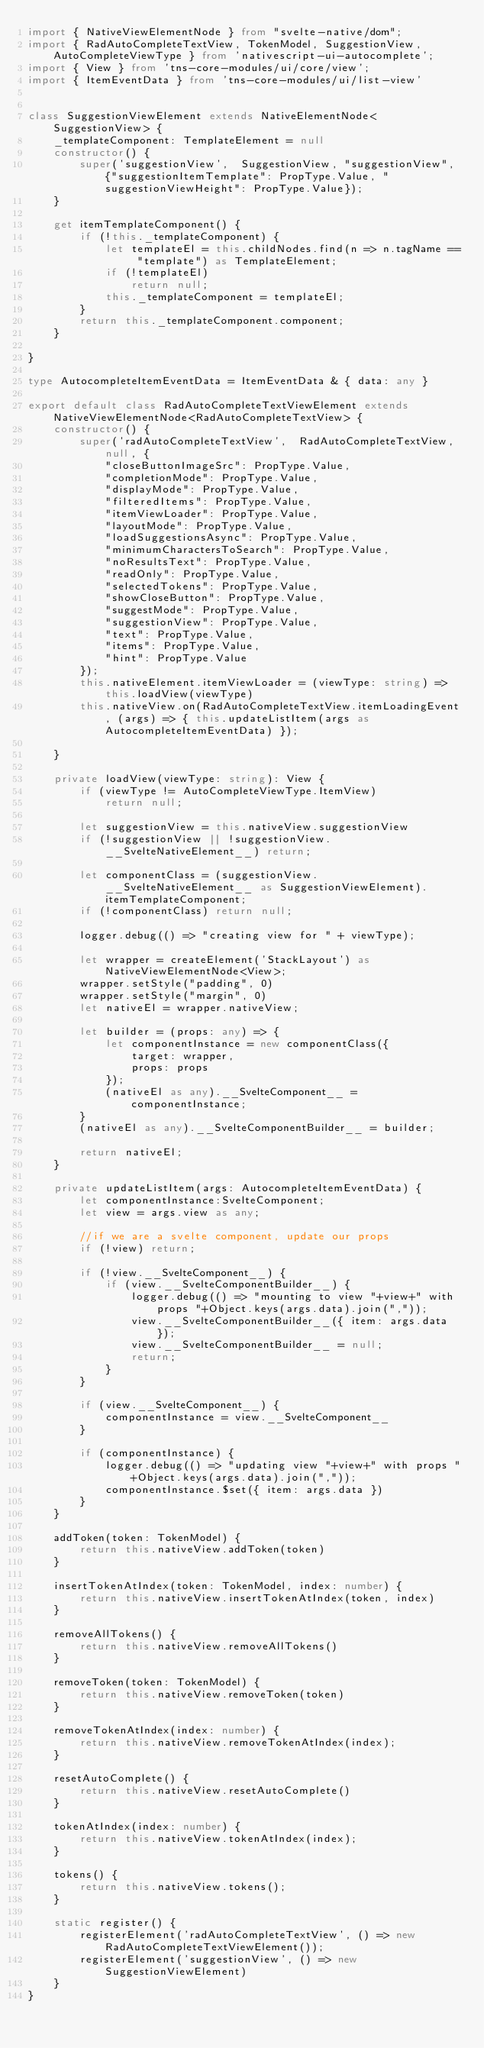Convert code to text. <code><loc_0><loc_0><loc_500><loc_500><_TypeScript_>import { NativeViewElementNode } from "svelte-native/dom";
import { RadAutoCompleteTextView, TokenModel, SuggestionView, AutoCompleteViewType } from 'nativescript-ui-autocomplete';
import { View } from 'tns-core-modules/ui/core/view';
import { ItemEventData } from 'tns-core-modules/ui/list-view'


class SuggestionViewElement extends NativeElementNode<SuggestionView> {
    _templateComponent: TemplateElement = null
    constructor() {
        super('suggestionView',  SuggestionView, "suggestionView", {"suggestionItemTemplate": PropType.Value, "suggestionViewHeight": PropType.Value});
    }

    get itemTemplateComponent() {
        if (!this._templateComponent) {
            let templateEl = this.childNodes.find(n => n.tagName == "template") as TemplateElement;
            if (!templateEl) 
                return null;
            this._templateComponent = templateEl;
        }
        return this._templateComponent.component;
    }
    
}

type AutocompleteItemEventData = ItemEventData & { data: any }

export default class RadAutoCompleteTextViewElement extends NativeViewElementNode<RadAutoCompleteTextView> {
    constructor() {
        super('radAutoCompleteTextView',  RadAutoCompleteTextView, null, {
            "closeButtonImageSrc": PropType.Value,
            "completionMode": PropType.Value,
            "displayMode": PropType.Value,
            "filteredItems": PropType.Value,
            "itemViewLoader": PropType.Value,
            "layoutMode": PropType.Value,
            "loadSuggestionsAsync": PropType.Value,
            "minimumCharactersToSearch": PropType.Value,
            "noResultsText": PropType.Value,
            "readOnly": PropType.Value,
            "selectedTokens": PropType.Value,
            "showCloseButton": PropType.Value,
            "suggestMode": PropType.Value,
            "suggestionView": PropType.Value,
            "text": PropType.Value,
            "items": PropType.Value,
            "hint": PropType.Value
        });
        this.nativeElement.itemViewLoader = (viewType: string) => this.loadView(viewType)
        this.nativeView.on(RadAutoCompleteTextView.itemLoadingEvent, (args) => { this.updateListItem(args as AutocompleteItemEventData) });

    }

    private loadView(viewType: string): View {
        if (viewType != AutoCompleteViewType.ItemView)
            return null;
        
        let suggestionView = this.nativeView.suggestionView
        if (!suggestionView || !suggestionView.__SvelteNativeElement__) return;

        let componentClass = (suggestionView.__SvelteNativeElement__ as SuggestionViewElement).itemTemplateComponent;
        if (!componentClass) return null;

        logger.debug(() => "creating view for " + viewType);

        let wrapper = createElement('StackLayout') as NativeViewElementNode<View>;
        wrapper.setStyle("padding", 0)
        wrapper.setStyle("margin", 0)
        let nativeEl = wrapper.nativeView;

        let builder = (props: any) => {
            let componentInstance = new componentClass({
                target: wrapper,
                props: props
            });
            (nativeEl as any).__SvelteComponent__ = componentInstance;
        }
        (nativeEl as any).__SvelteComponentBuilder__ = builder;
     
        return nativeEl;
    }
   
    private updateListItem(args: AutocompleteItemEventData) {
        let componentInstance:SvelteComponent;
        let view = args.view as any;

        //if we are a svelte component, update our props
        if (!view) return;

        if (!view.__SvelteComponent__) {
            if (view.__SvelteComponentBuilder__) {
                logger.debug(() => "mounting to view "+view+" with props "+Object.keys(args.data).join(","));
                view.__SvelteComponentBuilder__({ item: args.data });
                view.__SvelteComponentBuilder__ = null;
                return;
            }
        }

        if (view.__SvelteComponent__) {
            componentInstance = view.__SvelteComponent__
        }
    
        if (componentInstance) {
            logger.debug(() => "updating view "+view+" with props "+Object.keys(args.data).join(","));
            componentInstance.$set({ item: args.data })
        } 
    }

    addToken(token: TokenModel) {
        return this.nativeView.addToken(token)
    }

    insertTokenAtIndex(token: TokenModel, index: number) {
        return this.nativeView.insertTokenAtIndex(token, index)
    }

    removeAllTokens() {
        return this.nativeView.removeAllTokens()
    }

    removeToken(token: TokenModel) {
        return this.nativeView.removeToken(token)
    }

    removeTokenAtIndex(index: number) {
        return this.nativeView.removeTokenAtIndex(index);
    }

    resetAutoComplete() {
        return this.nativeView.resetAutoComplete()
    }

    tokenAtIndex(index: number) {
        return this.nativeView.tokenAtIndex(index);
    }

    tokens() {
        return this.nativeView.tokens();
    }

    static register() {
        registerElement('radAutoCompleteTextView', () => new RadAutoCompleteTextViewElement());
        registerElement('suggestionView', () => new SuggestionViewElement)
    }
}
</code> 